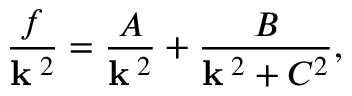<formula> <loc_0><loc_0><loc_500><loc_500>{ \frac { f } { { k } ^ { \, 2 } } } = { \frac { A } { { k } ^ { \, 2 } } } + { \frac { B } { { k } ^ { \, 2 } + C ^ { 2 } } } ,</formula> 